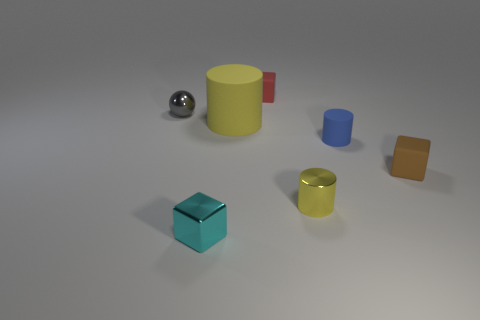Add 1 cyan blocks. How many objects exist? 8 Subtract all cubes. How many objects are left? 4 Add 7 yellow blocks. How many yellow blocks exist? 7 Subtract 1 brown blocks. How many objects are left? 6 Subtract all blue things. Subtract all blue cylinders. How many objects are left? 5 Add 1 tiny matte cylinders. How many tiny matte cylinders are left? 2 